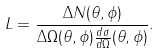<formula> <loc_0><loc_0><loc_500><loc_500>L = \frac { \Delta N ( \theta , \phi ) } { \Delta \Omega ( \theta , \phi ) \frac { d \sigma } { d \Omega } ( \theta , \phi ) } .</formula> 